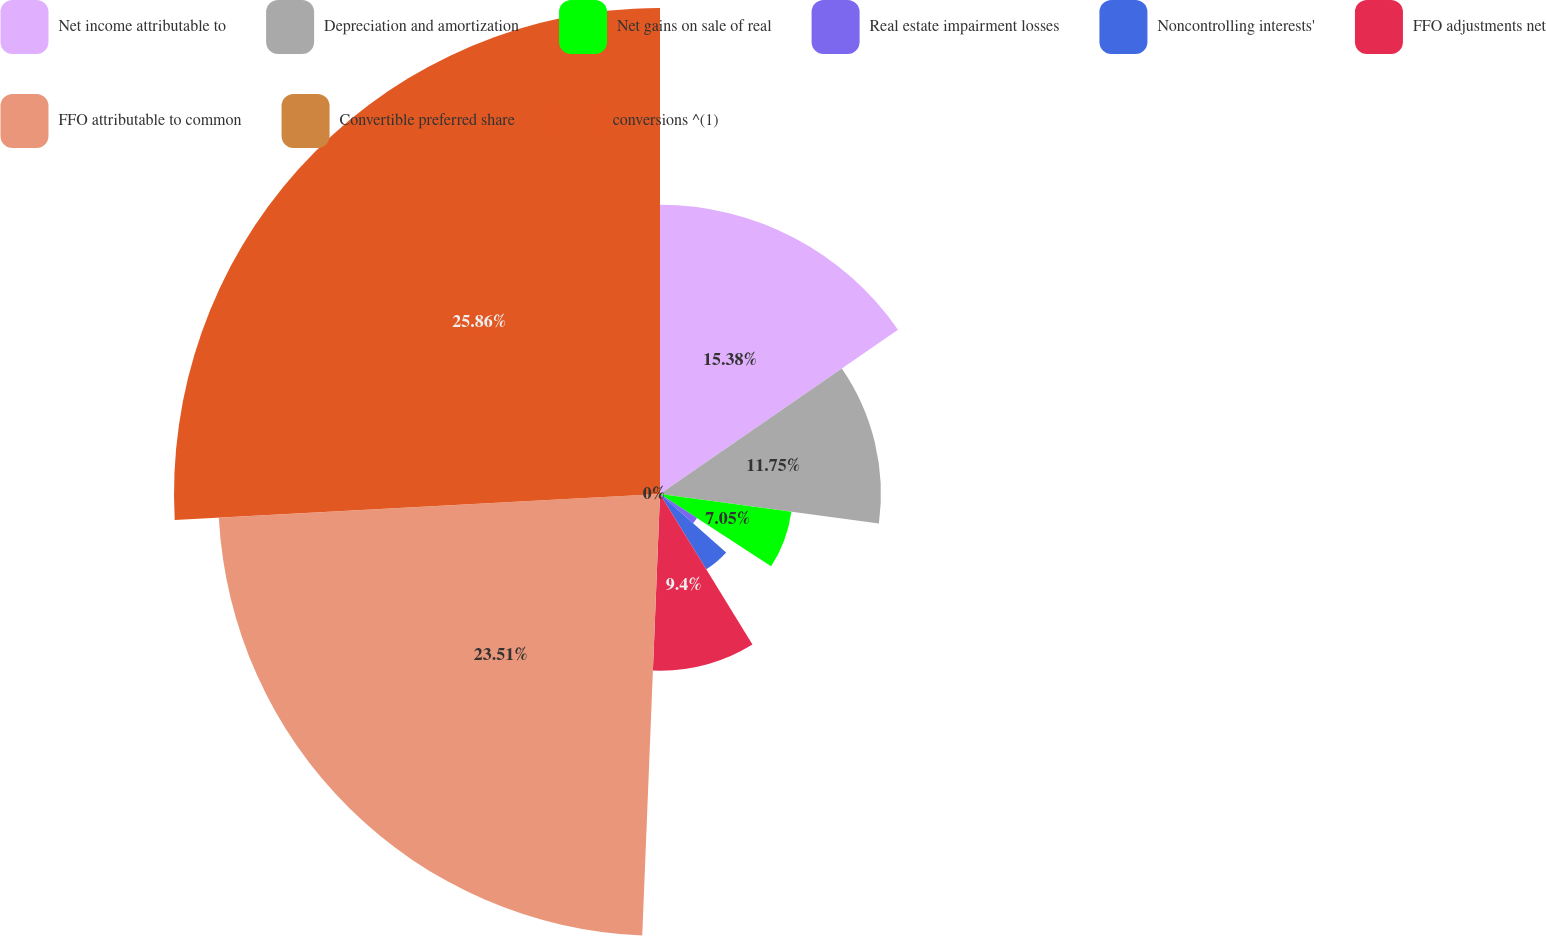Convert chart. <chart><loc_0><loc_0><loc_500><loc_500><pie_chart><fcel>Net income attributable to<fcel>Depreciation and amortization<fcel>Net gains on sale of real<fcel>Real estate impairment losses<fcel>Noncontrolling interests'<fcel>FFO adjustments net<fcel>FFO attributable to common<fcel>Convertible preferred share<fcel>conversions ^(1)<nl><fcel>15.38%<fcel>11.75%<fcel>7.05%<fcel>2.35%<fcel>4.7%<fcel>9.4%<fcel>23.5%<fcel>0.0%<fcel>25.85%<nl></chart> 